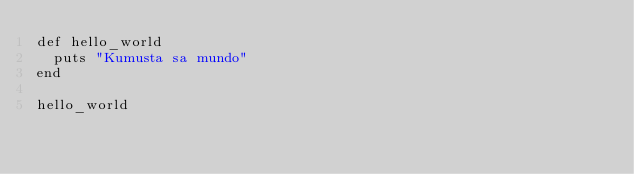Convert code to text. <code><loc_0><loc_0><loc_500><loc_500><_Ruby_>def hello_world
  puts "Kumusta sa mundo"
end

hello_world
</code> 